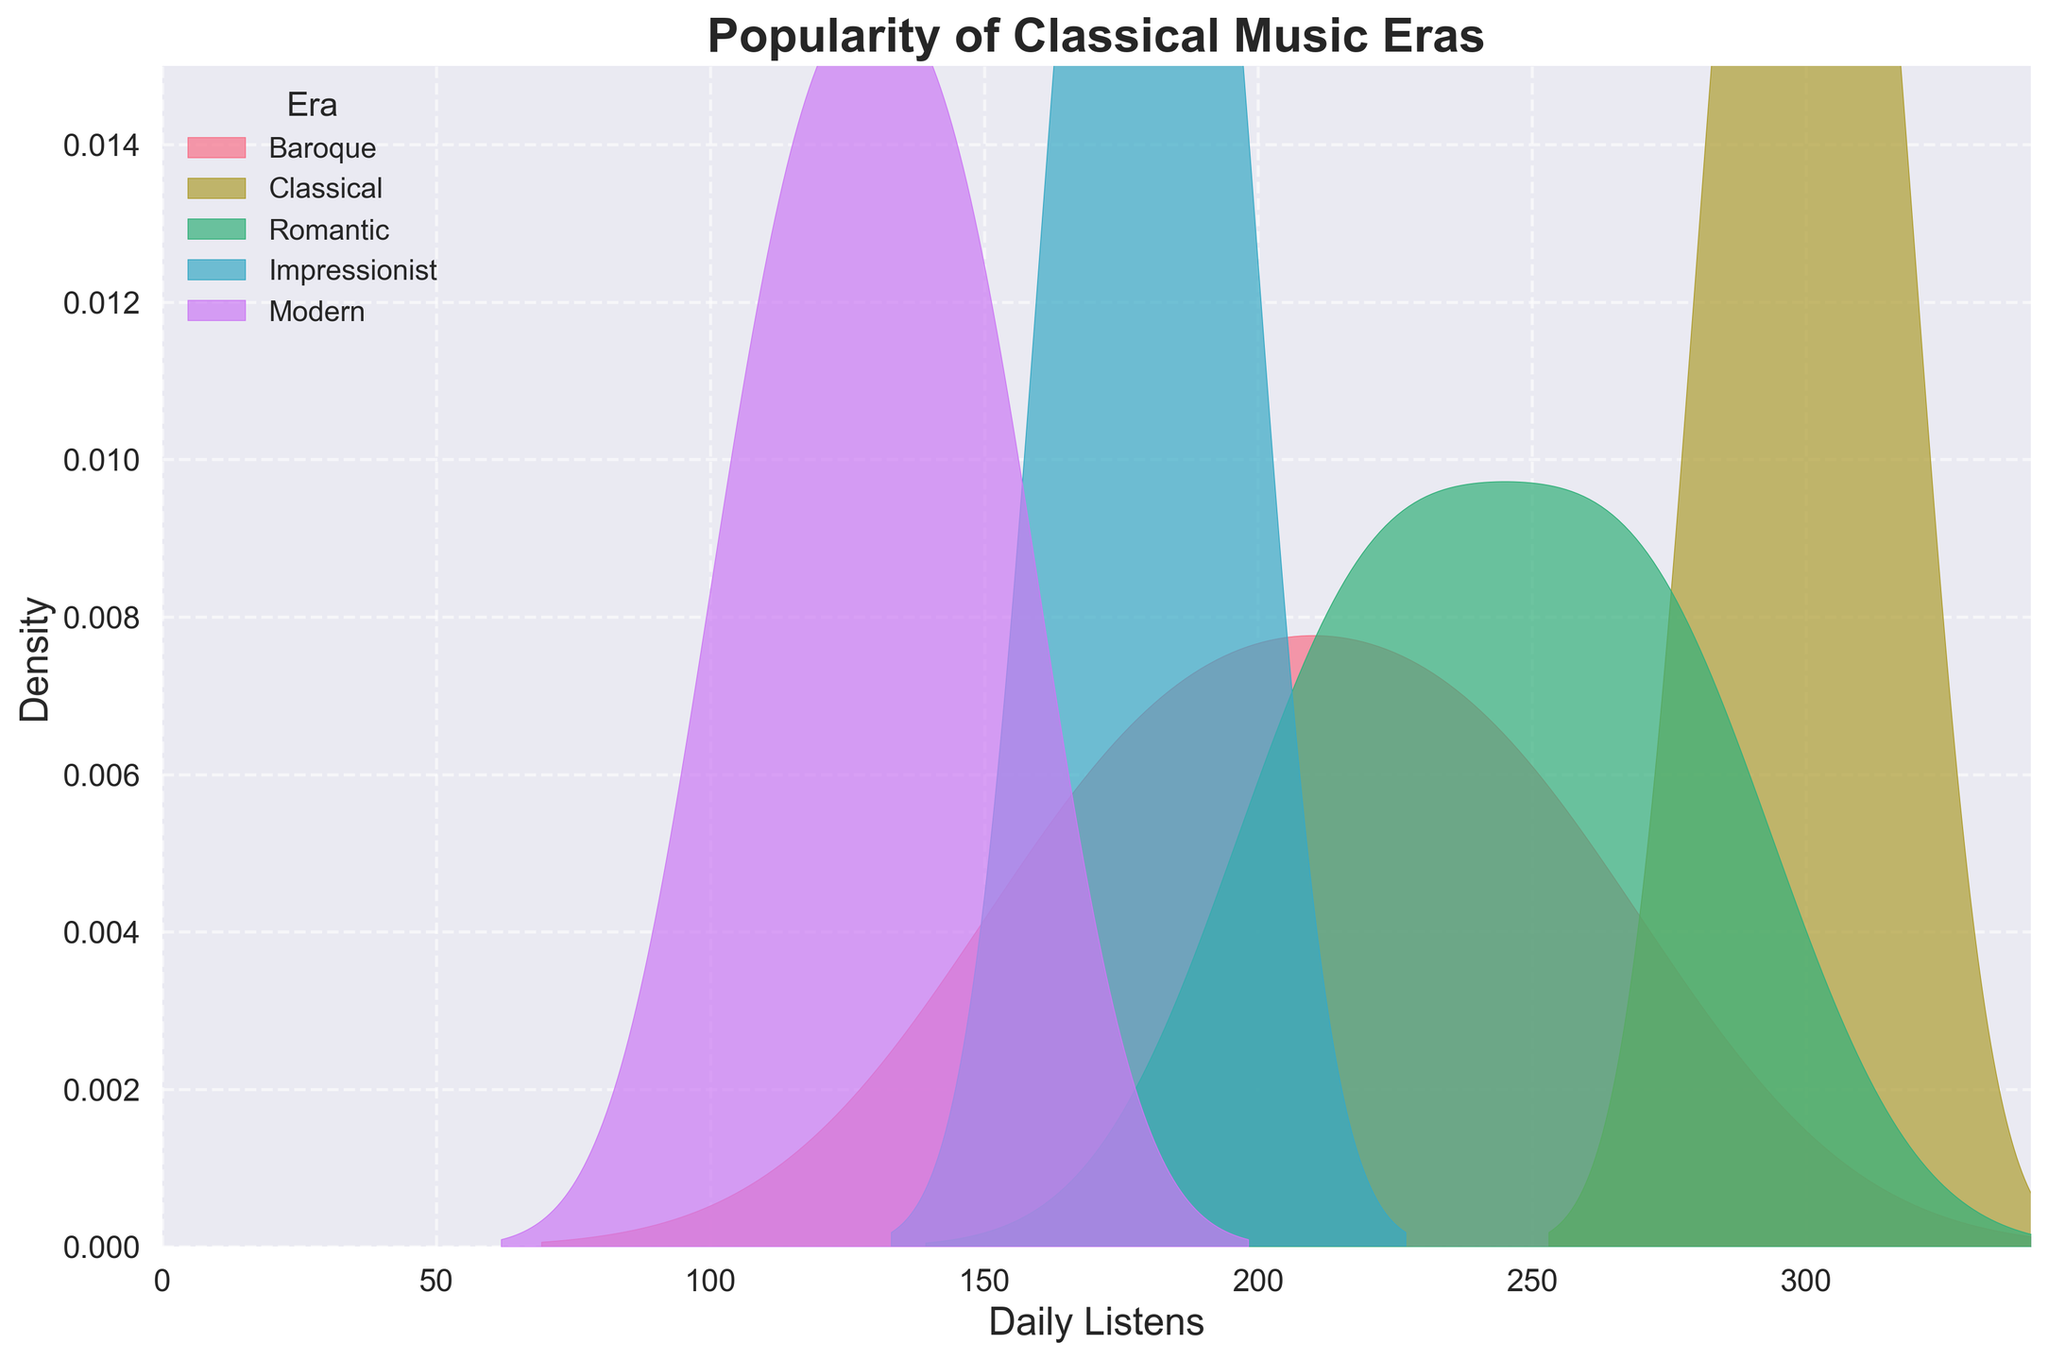What's the title of the figure? The title is usually stated at the top of the plot. Here, it reads "Popularity of Classical Music Eras."
Answer: Popularity of Classical Music Eras What's the x-axis representing? The label on the x-axis typically tells us what data is plotted in that dimension. Here it says "Daily Listens," meaning it represents the number of daily listens.
Answer: Daily Listens Which era has the highest density peak? By looking at the density peaks in the plot, we identify the highest one. The Classical era exhibits the highest peak among all eras plotted.
Answer: Classical What is the maximum x-axis value shown in the plot? The x-axis is labeled from 0 to a certain value. Here, the maximum is slightly above 340, which is 1.1 times the highest value of daily listens (310 for Mozart).
Answer: Around 340 Which two eras show the closest density distributions in terms of their peaks? To find the closest distributions, compare the peak values of each era. The Impressionist and Romantic eras have close peak densities.
Answer: Romantic and Impressionist How do the densities of Baroque and Modern eras compare? By comparing the peak densities of Baroque and Modern eras, the Baroque era's density is higher than that of the Modern era.
Answer: Baroque's density is higher than Modern's Which eras are represented with their density peaks above a daily listen value of 200? Observing each era's density peak, those of Classical, Romantic, and Baroque peak above the daily listen value of 200.
Answer: Classical, Romantic, Baroque How many unique colors are used in the plot, and what does each represent? By counting the distinct shades in the density plots and noting the legend, there are five unique colors representing each of the five eras.
Answer: Five, each representing an era What is the range of the y-axis, and what does it represent? Observing the y-axis from bottom to top, the range is from 0 to 0.015. This axis represents the density of daily listens.
Answer: 0 to 0.015, density Which eras have density plots that noticeably overlap each other? By examining the overlapping regions, the Romantic and Impressionist eras exhibit noticeable overlap.
Answer: Romantic and Impressionist 